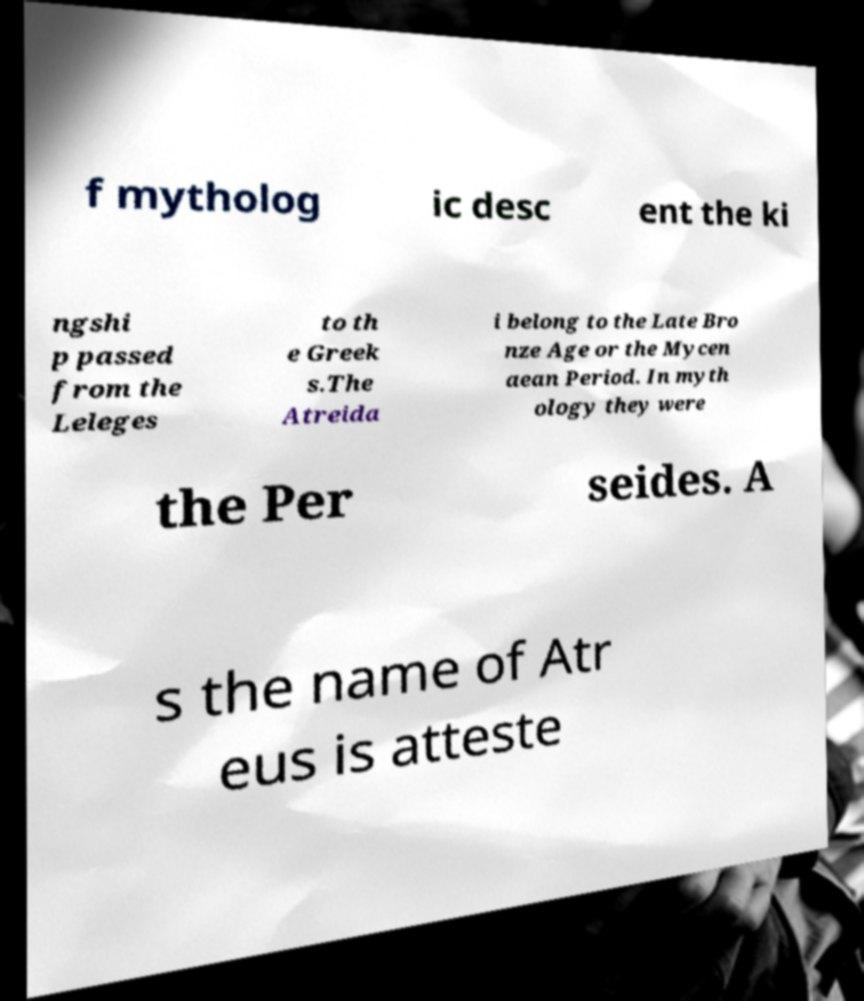I need the written content from this picture converted into text. Can you do that? f mytholog ic desc ent the ki ngshi p passed from the Leleges to th e Greek s.The Atreida i belong to the Late Bro nze Age or the Mycen aean Period. In myth ology they were the Per seides. A s the name of Atr eus is atteste 